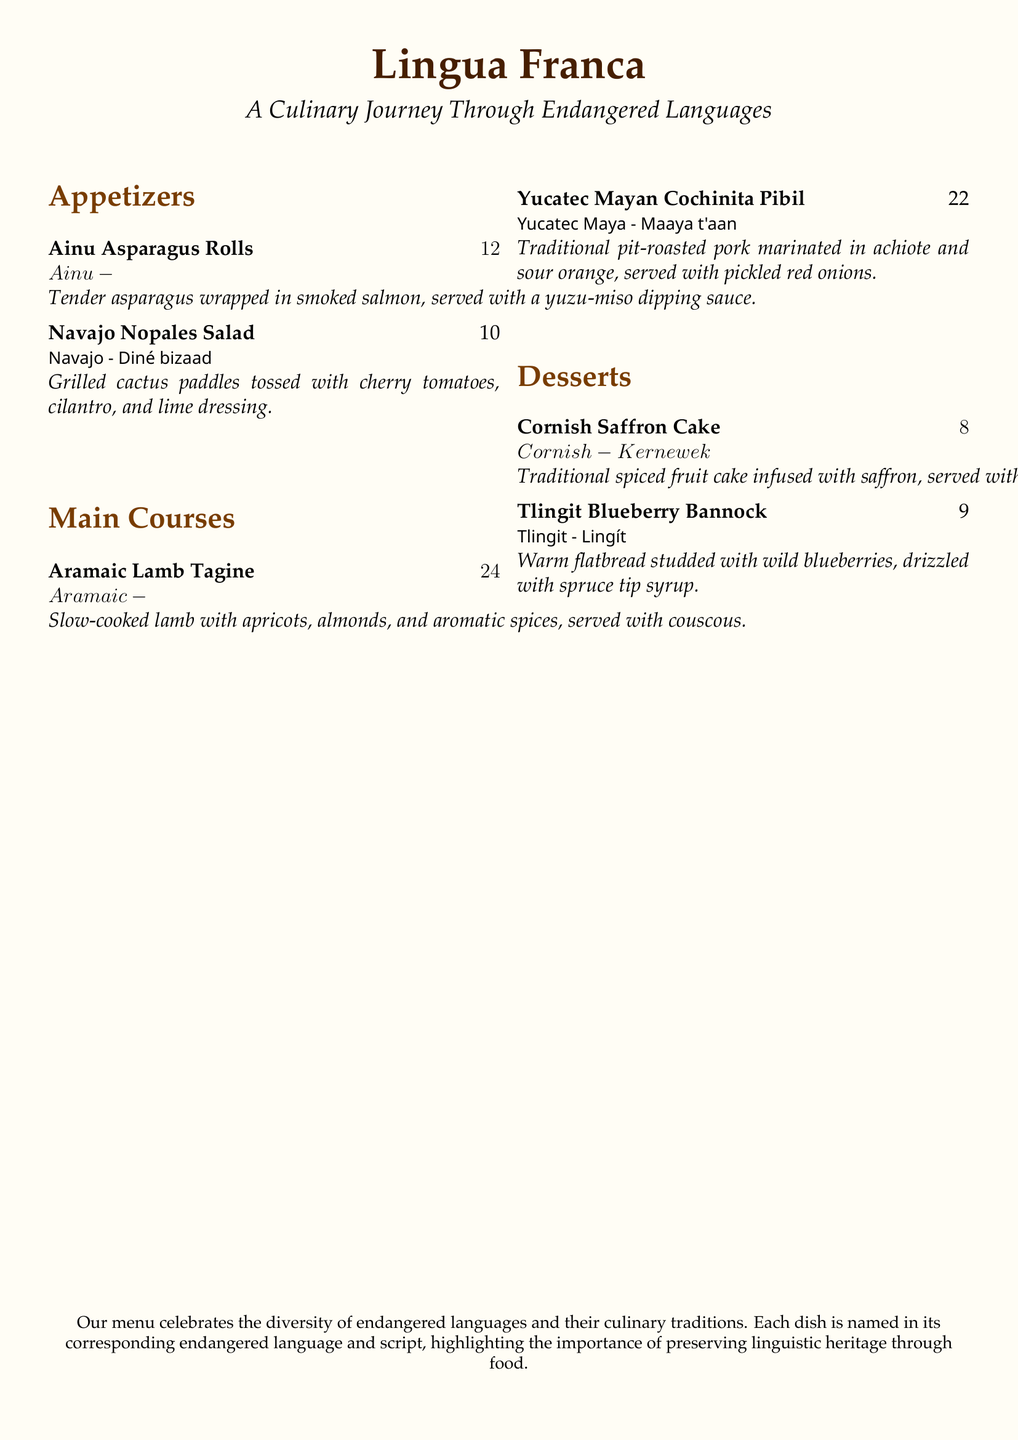What is the name of the restaurant? The restaurant is titled "Lingua Franca" as stated at the top of the menu.
Answer: Lingua Franca How many appetizers are listed on the menu? The menu lists two appetizers under the appetizers section.
Answer: 2 What is the price of the Aramaic Lamb Tagine? The price for the Aramaic Lamb Tagine is displayed next to the dish.
Answer: $24 Which endangered language is represented by the Tlingit Blueberry Bannock? The dish Tlingit Blueberry Bannock is named after the Tlingit language, as shown in the menu.
Answer: Tlingit What type of dish is the Cornish Saffron Cake? The description categorizes the Cornish Saffron Cake as a dessert.
Answer: Dessert What is the primary ingredient in the Navajo Nopales Salad? The main ingredient mentioned for the Navajo Nopales Salad is grilled cactus paddles.
Answer: Cactus paddles Which dish features wild blueberries? The Tlingit Blueberry Bannock is the dish that features wild blueberries, as indicated in its description.
Answer: Tlingit Blueberry Bannock What culinary tradition does the menu celebrate? The menu highlights the preservation of linguistic heritage through food, celebrating endangered languages and their traditions.
Answer: Endangered languages 